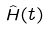Convert formula to latex. <formula><loc_0><loc_0><loc_500><loc_500>\hat { H } ( t )</formula> 